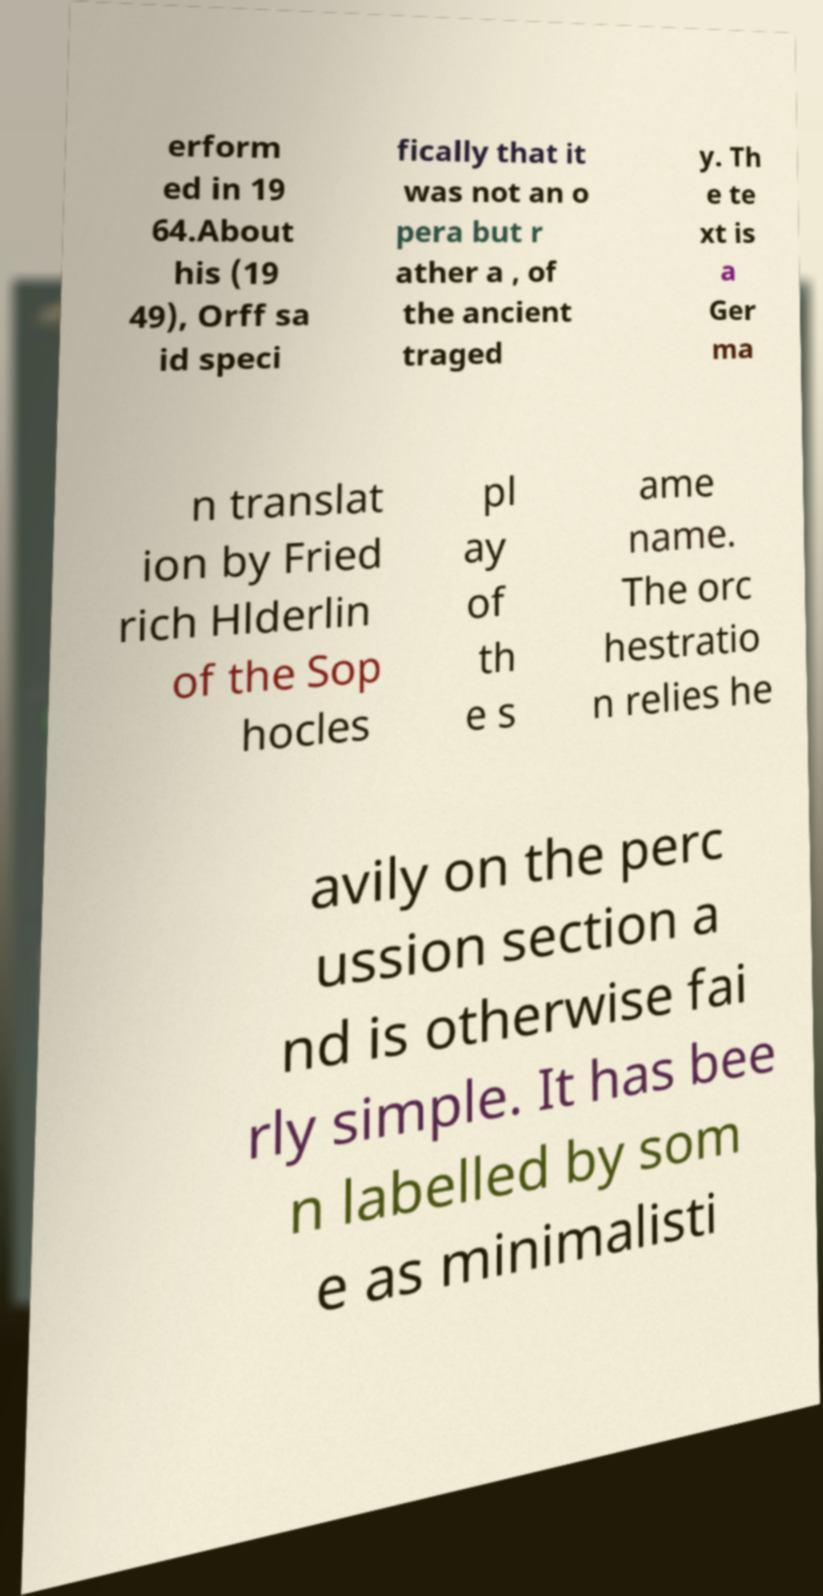There's text embedded in this image that I need extracted. Can you transcribe it verbatim? erform ed in 19 64.About his (19 49), Orff sa id speci fically that it was not an o pera but r ather a , of the ancient traged y. Th e te xt is a Ger ma n translat ion by Fried rich Hlderlin of the Sop hocles pl ay of th e s ame name. The orc hestratio n relies he avily on the perc ussion section a nd is otherwise fai rly simple. It has bee n labelled by som e as minimalisti 